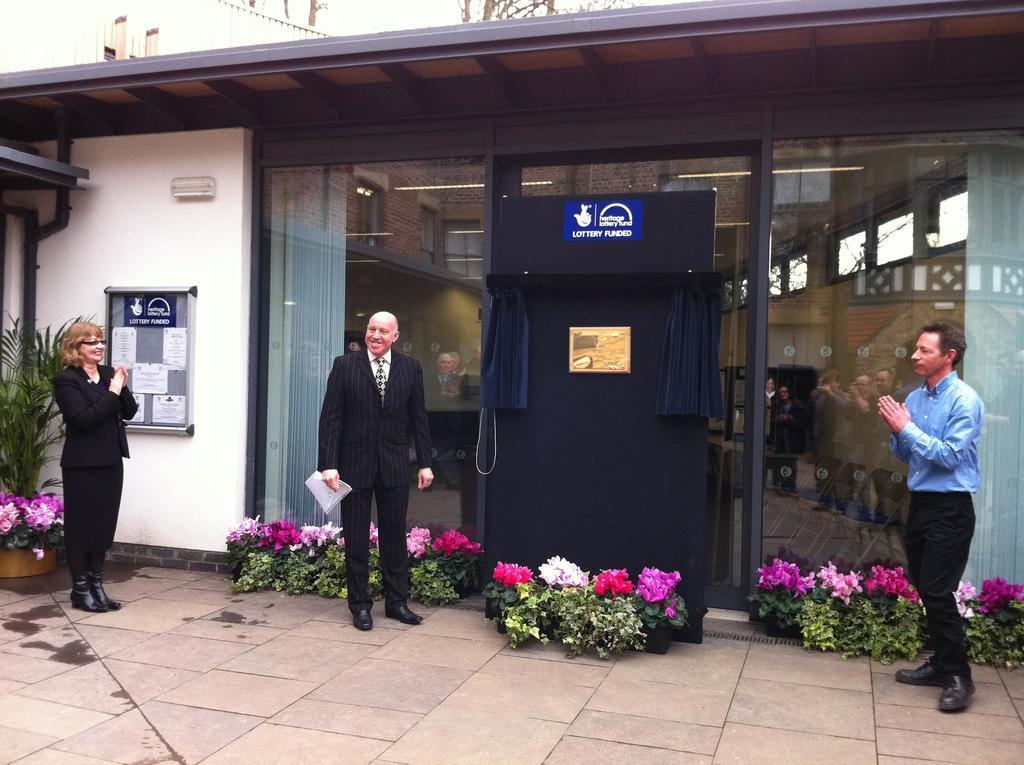Who funded this project?
Provide a succinct answer. Unanswerable. What does it say on the blue sign?
Provide a succinct answer. Lottery funded. 